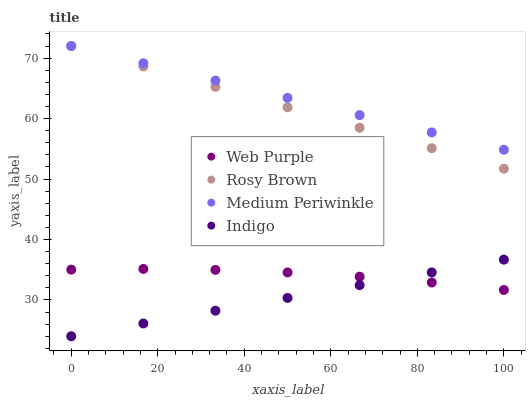Does Indigo have the minimum area under the curve?
Answer yes or no. Yes. Does Medium Periwinkle have the maximum area under the curve?
Answer yes or no. Yes. Does Web Purple have the minimum area under the curve?
Answer yes or no. No. Does Web Purple have the maximum area under the curve?
Answer yes or no. No. Is Rosy Brown the smoothest?
Answer yes or no. Yes. Is Web Purple the roughest?
Answer yes or no. Yes. Is Web Purple the smoothest?
Answer yes or no. No. Is Rosy Brown the roughest?
Answer yes or no. No. Does Indigo have the lowest value?
Answer yes or no. Yes. Does Web Purple have the lowest value?
Answer yes or no. No. Does Medium Periwinkle have the highest value?
Answer yes or no. Yes. Does Web Purple have the highest value?
Answer yes or no. No. Is Indigo less than Rosy Brown?
Answer yes or no. Yes. Is Medium Periwinkle greater than Indigo?
Answer yes or no. Yes. Does Web Purple intersect Indigo?
Answer yes or no. Yes. Is Web Purple less than Indigo?
Answer yes or no. No. Is Web Purple greater than Indigo?
Answer yes or no. No. Does Indigo intersect Rosy Brown?
Answer yes or no. No. 